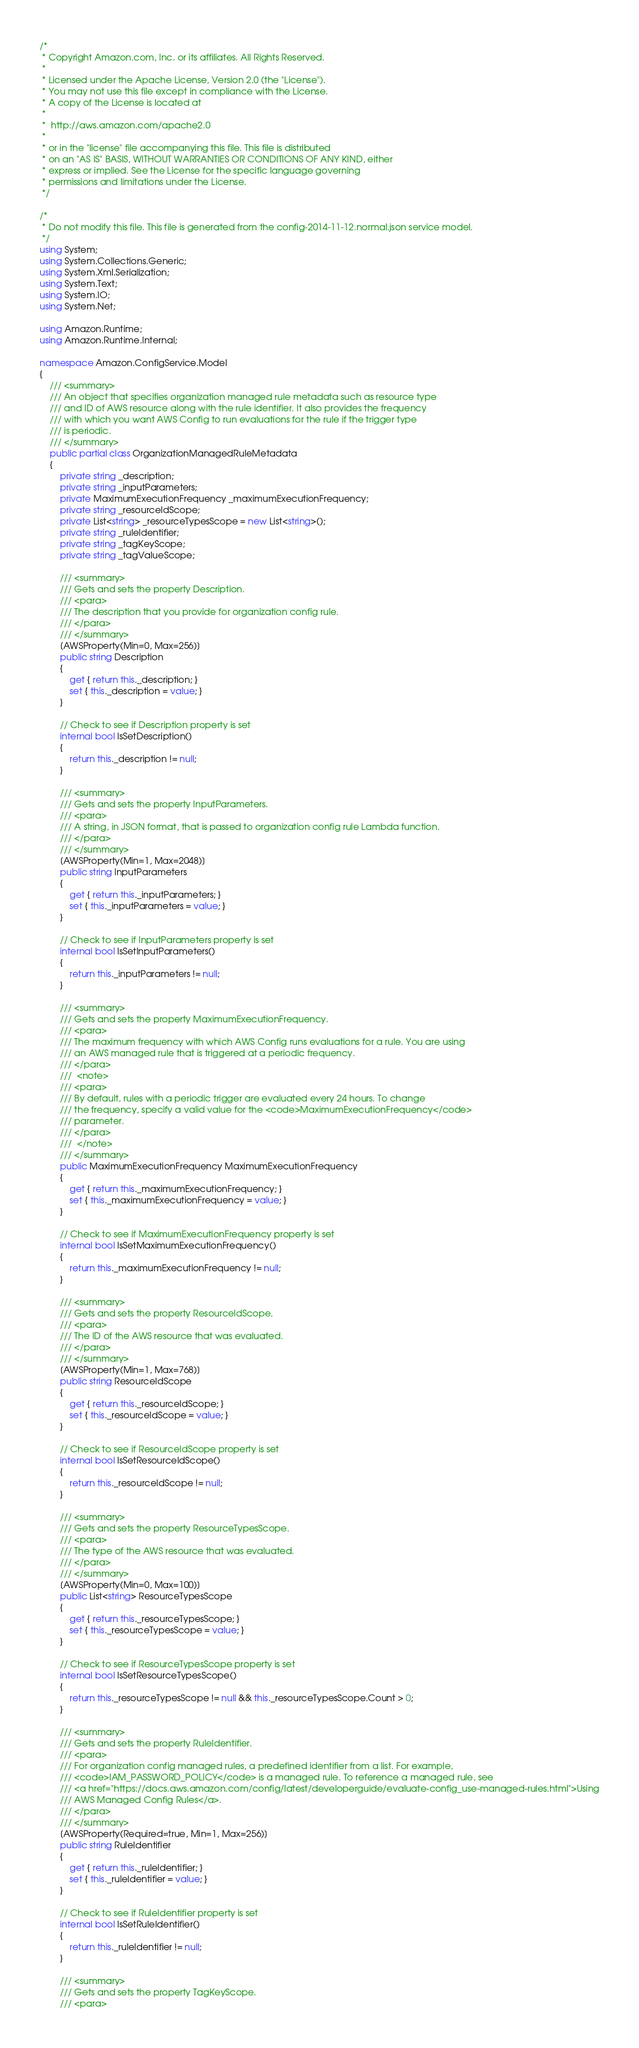Convert code to text. <code><loc_0><loc_0><loc_500><loc_500><_C#_>/*
 * Copyright Amazon.com, Inc. or its affiliates. All Rights Reserved.
 * 
 * Licensed under the Apache License, Version 2.0 (the "License").
 * You may not use this file except in compliance with the License.
 * A copy of the License is located at
 * 
 *  http://aws.amazon.com/apache2.0
 * 
 * or in the "license" file accompanying this file. This file is distributed
 * on an "AS IS" BASIS, WITHOUT WARRANTIES OR CONDITIONS OF ANY KIND, either
 * express or implied. See the License for the specific language governing
 * permissions and limitations under the License.
 */

/*
 * Do not modify this file. This file is generated from the config-2014-11-12.normal.json service model.
 */
using System;
using System.Collections.Generic;
using System.Xml.Serialization;
using System.Text;
using System.IO;
using System.Net;

using Amazon.Runtime;
using Amazon.Runtime.Internal;

namespace Amazon.ConfigService.Model
{
    /// <summary>
    /// An object that specifies organization managed rule metadata such as resource type
    /// and ID of AWS resource along with the rule identifier. It also provides the frequency
    /// with which you want AWS Config to run evaluations for the rule if the trigger type
    /// is periodic.
    /// </summary>
    public partial class OrganizationManagedRuleMetadata
    {
        private string _description;
        private string _inputParameters;
        private MaximumExecutionFrequency _maximumExecutionFrequency;
        private string _resourceIdScope;
        private List<string> _resourceTypesScope = new List<string>();
        private string _ruleIdentifier;
        private string _tagKeyScope;
        private string _tagValueScope;

        /// <summary>
        /// Gets and sets the property Description. 
        /// <para>
        /// The description that you provide for organization config rule.
        /// </para>
        /// </summary>
        [AWSProperty(Min=0, Max=256)]
        public string Description
        {
            get { return this._description; }
            set { this._description = value; }
        }

        // Check to see if Description property is set
        internal bool IsSetDescription()
        {
            return this._description != null;
        }

        /// <summary>
        /// Gets and sets the property InputParameters. 
        /// <para>
        /// A string, in JSON format, that is passed to organization config rule Lambda function.
        /// </para>
        /// </summary>
        [AWSProperty(Min=1, Max=2048)]
        public string InputParameters
        {
            get { return this._inputParameters; }
            set { this._inputParameters = value; }
        }

        // Check to see if InputParameters property is set
        internal bool IsSetInputParameters()
        {
            return this._inputParameters != null;
        }

        /// <summary>
        /// Gets and sets the property MaximumExecutionFrequency. 
        /// <para>
        /// The maximum frequency with which AWS Config runs evaluations for a rule. You are using
        /// an AWS managed rule that is triggered at a periodic frequency.
        /// </para>
        ///  <note> 
        /// <para>
        /// By default, rules with a periodic trigger are evaluated every 24 hours. To change
        /// the frequency, specify a valid value for the <code>MaximumExecutionFrequency</code>
        /// parameter.
        /// </para>
        ///  </note>
        /// </summary>
        public MaximumExecutionFrequency MaximumExecutionFrequency
        {
            get { return this._maximumExecutionFrequency; }
            set { this._maximumExecutionFrequency = value; }
        }

        // Check to see if MaximumExecutionFrequency property is set
        internal bool IsSetMaximumExecutionFrequency()
        {
            return this._maximumExecutionFrequency != null;
        }

        /// <summary>
        /// Gets and sets the property ResourceIdScope. 
        /// <para>
        /// The ID of the AWS resource that was evaluated.
        /// </para>
        /// </summary>
        [AWSProperty(Min=1, Max=768)]
        public string ResourceIdScope
        {
            get { return this._resourceIdScope; }
            set { this._resourceIdScope = value; }
        }

        // Check to see if ResourceIdScope property is set
        internal bool IsSetResourceIdScope()
        {
            return this._resourceIdScope != null;
        }

        /// <summary>
        /// Gets and sets the property ResourceTypesScope. 
        /// <para>
        /// The type of the AWS resource that was evaluated.
        /// </para>
        /// </summary>
        [AWSProperty(Min=0, Max=100)]
        public List<string> ResourceTypesScope
        {
            get { return this._resourceTypesScope; }
            set { this._resourceTypesScope = value; }
        }

        // Check to see if ResourceTypesScope property is set
        internal bool IsSetResourceTypesScope()
        {
            return this._resourceTypesScope != null && this._resourceTypesScope.Count > 0; 
        }

        /// <summary>
        /// Gets and sets the property RuleIdentifier. 
        /// <para>
        /// For organization config managed rules, a predefined identifier from a list. For example,
        /// <code>IAM_PASSWORD_POLICY</code> is a managed rule. To reference a managed rule, see
        /// <a href="https://docs.aws.amazon.com/config/latest/developerguide/evaluate-config_use-managed-rules.html">Using
        /// AWS Managed Config Rules</a>.
        /// </para>
        /// </summary>
        [AWSProperty(Required=true, Min=1, Max=256)]
        public string RuleIdentifier
        {
            get { return this._ruleIdentifier; }
            set { this._ruleIdentifier = value; }
        }

        // Check to see if RuleIdentifier property is set
        internal bool IsSetRuleIdentifier()
        {
            return this._ruleIdentifier != null;
        }

        /// <summary>
        /// Gets and sets the property TagKeyScope. 
        /// <para></code> 